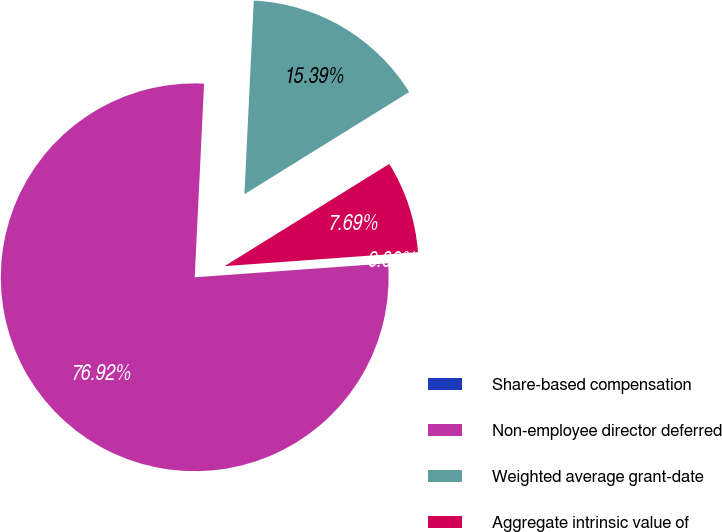Convert chart to OTSL. <chart><loc_0><loc_0><loc_500><loc_500><pie_chart><fcel>Share-based compensation<fcel>Non-employee director deferred<fcel>Weighted average grant-date<fcel>Aggregate intrinsic value of<nl><fcel>0.0%<fcel>76.92%<fcel>15.39%<fcel>7.69%<nl></chart> 